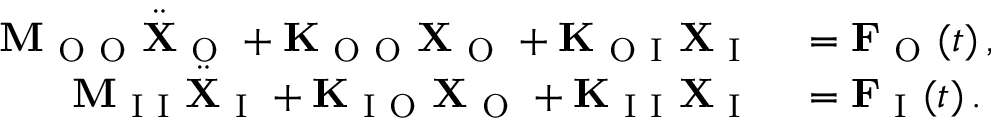<formula> <loc_0><loc_0><loc_500><loc_500>\begin{array} { r l } { M _ { O O } \ddot { X } _ { O } + K _ { O O } X _ { O } + K _ { O I } X _ { I } } & = F _ { O } ( t ) \, , } \\ { M _ { I I } \ddot { X } _ { I } + K _ { I O } X _ { O } + K _ { I I } X _ { I } } & = F _ { I } ( t ) \, . } \end{array}</formula> 